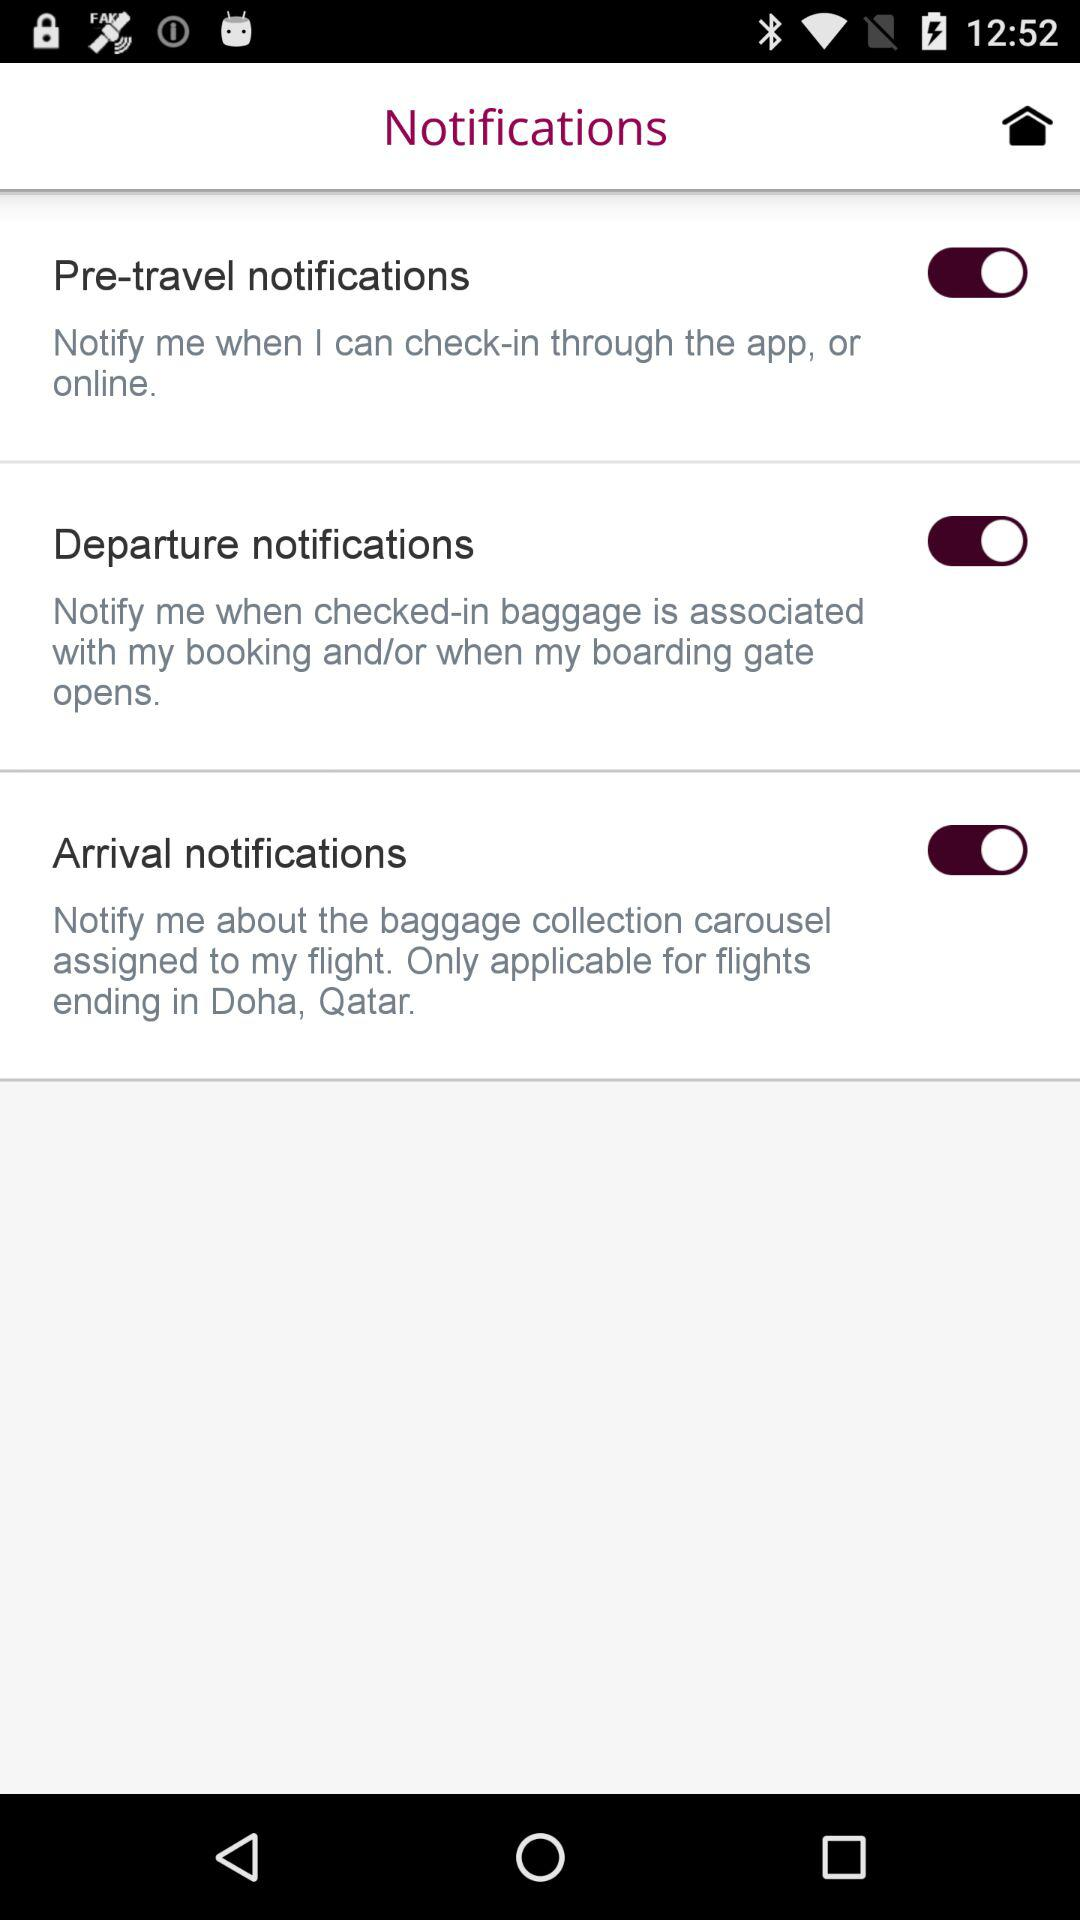How many notifications are available?
Answer the question using a single word or phrase. 3 